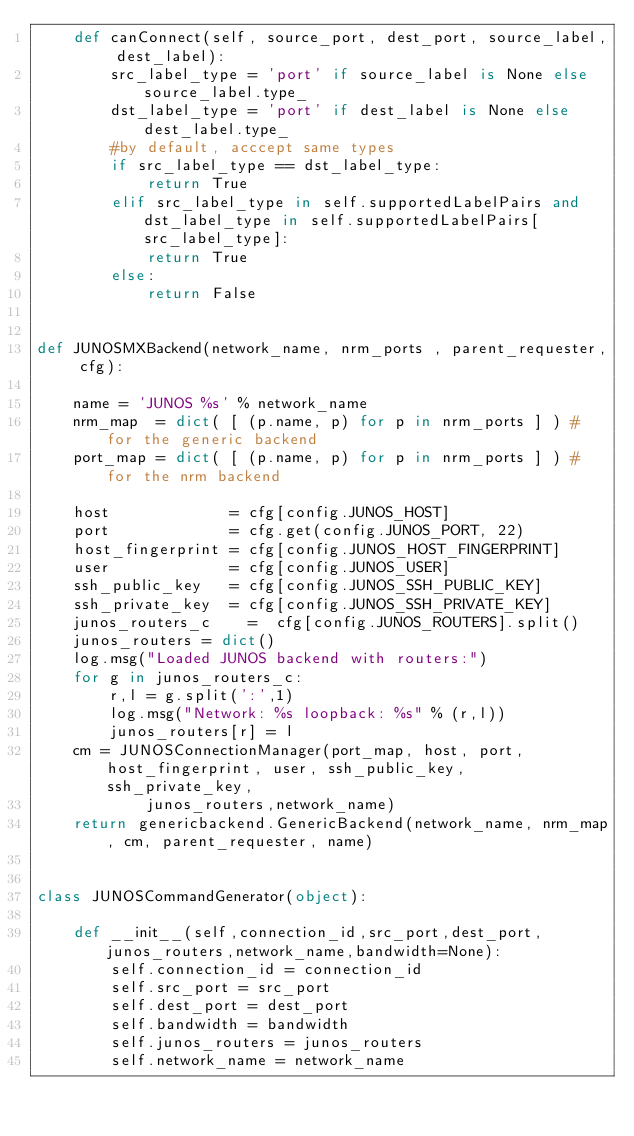<code> <loc_0><loc_0><loc_500><loc_500><_Python_>    def canConnect(self, source_port, dest_port, source_label, dest_label):
        src_label_type = 'port' if source_label is None else source_label.type_
        dst_label_type = 'port' if dest_label is None else dest_label.type_
        #by default, acccept same types
        if src_label_type == dst_label_type:
            return True
        elif src_label_type in self.supportedLabelPairs and dst_label_type in self.supportedLabelPairs[src_label_type]:
            return True
        else: 
            return False


def JUNOSMXBackend(network_name, nrm_ports , parent_requester, cfg):

    name = 'JUNOS %s' % network_name
    nrm_map  = dict( [ (p.name, p) for p in nrm_ports ] ) # for the generic backend
    port_map = dict( [ (p.name, p) for p in nrm_ports ] ) # for the nrm backend

    host             = cfg[config.JUNOS_HOST]
    port             = cfg.get(config.JUNOS_PORT, 22)
    host_fingerprint = cfg[config.JUNOS_HOST_FINGERPRINT]
    user             = cfg[config.JUNOS_USER]
    ssh_public_key   = cfg[config.JUNOS_SSH_PUBLIC_KEY]
    ssh_private_key  = cfg[config.JUNOS_SSH_PRIVATE_KEY]
    junos_routers_c    =  cfg[config.JUNOS_ROUTERS].split()
    junos_routers = dict()
    log.msg("Loaded JUNOS backend with routers:")
    for g in junos_routers_c:
        r,l = g.split(':',1)
        log.msg("Network: %s loopback: %s" % (r,l))
        junos_routers[r] = l
    cm = JUNOSConnectionManager(port_map, host, port, host_fingerprint, user, ssh_public_key, ssh_private_key,
            junos_routers,network_name)
    return genericbackend.GenericBackend(network_name, nrm_map, cm, parent_requester, name)


class JUNOSCommandGenerator(object):

    def __init__(self,connection_id,src_port,dest_port,junos_routers,network_name,bandwidth=None):
        self.connection_id = connection_id
        self.src_port = src_port
        self.dest_port = dest_port
        self.bandwidth = bandwidth
        self.junos_routers = junos_routers
        self.network_name = network_name</code> 